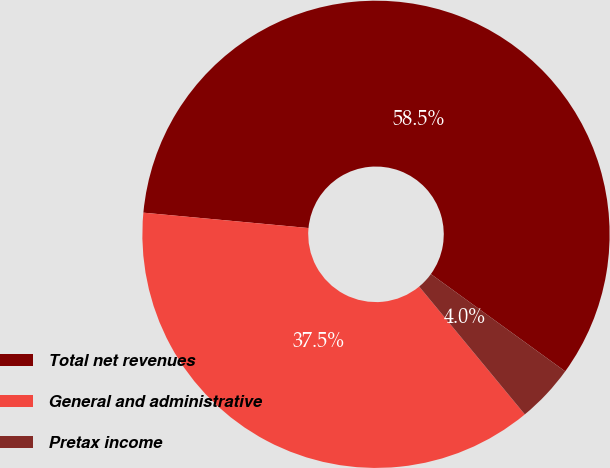Convert chart. <chart><loc_0><loc_0><loc_500><loc_500><pie_chart><fcel>Total net revenues<fcel>General and administrative<fcel>Pretax income<nl><fcel>58.5%<fcel>37.47%<fcel>4.03%<nl></chart> 